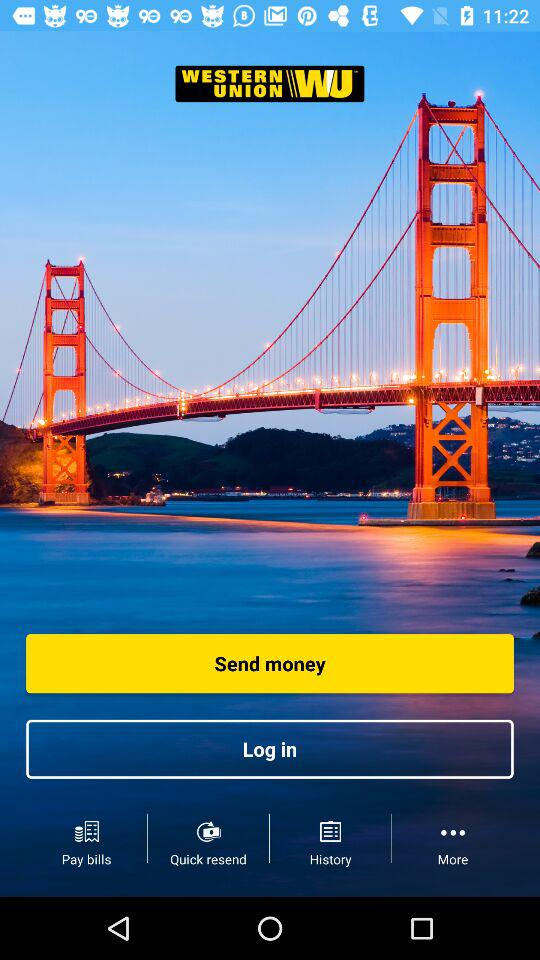What is the app name? The application name is "WESTERN UNION". 